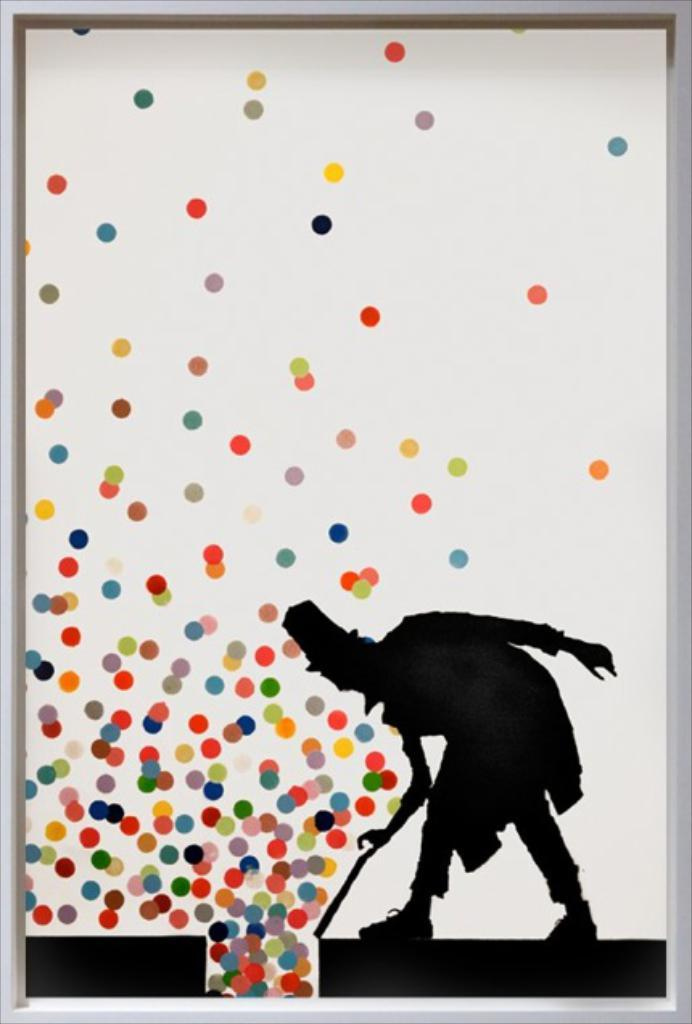What is the main object in the image? There is a frame in the image. What can be seen inside the frame? A person is depicted in the frame. What is the person holding in the image? The person is holding a stick. What other visual elements are present in the image? There are colorful dots in the image. How would you describe the overall nature of the image? The image is a depiction picture. What type of knot is the person tying in the image? There is no knot-tying activity depicted in the image; the person is holding a stick. How many judges are present in the image? There are no judges present in the image; it features a person holding a stick in a frame with colorful dots. 